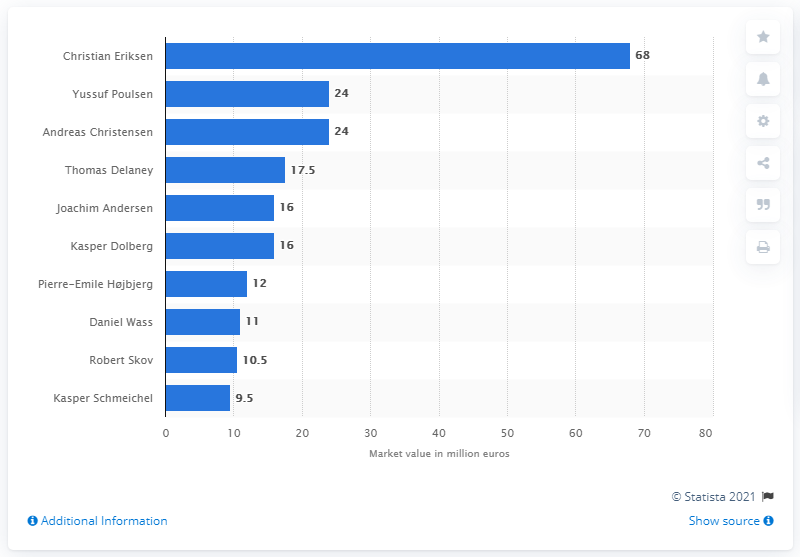Point out several critical features in this image. Christian Eriksen was the most valuable player of the national football team of Denmark. As of 2020, Christian Eriksen's market value was estimated to be 68. The market value of Poulsen and Christensen was approximately 24 million dollars. 